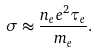Convert formula to latex. <formula><loc_0><loc_0><loc_500><loc_500>\sigma \approx \frac { n _ { e } e ^ { 2 } \tau _ { e } } { m _ { e } } .</formula> 